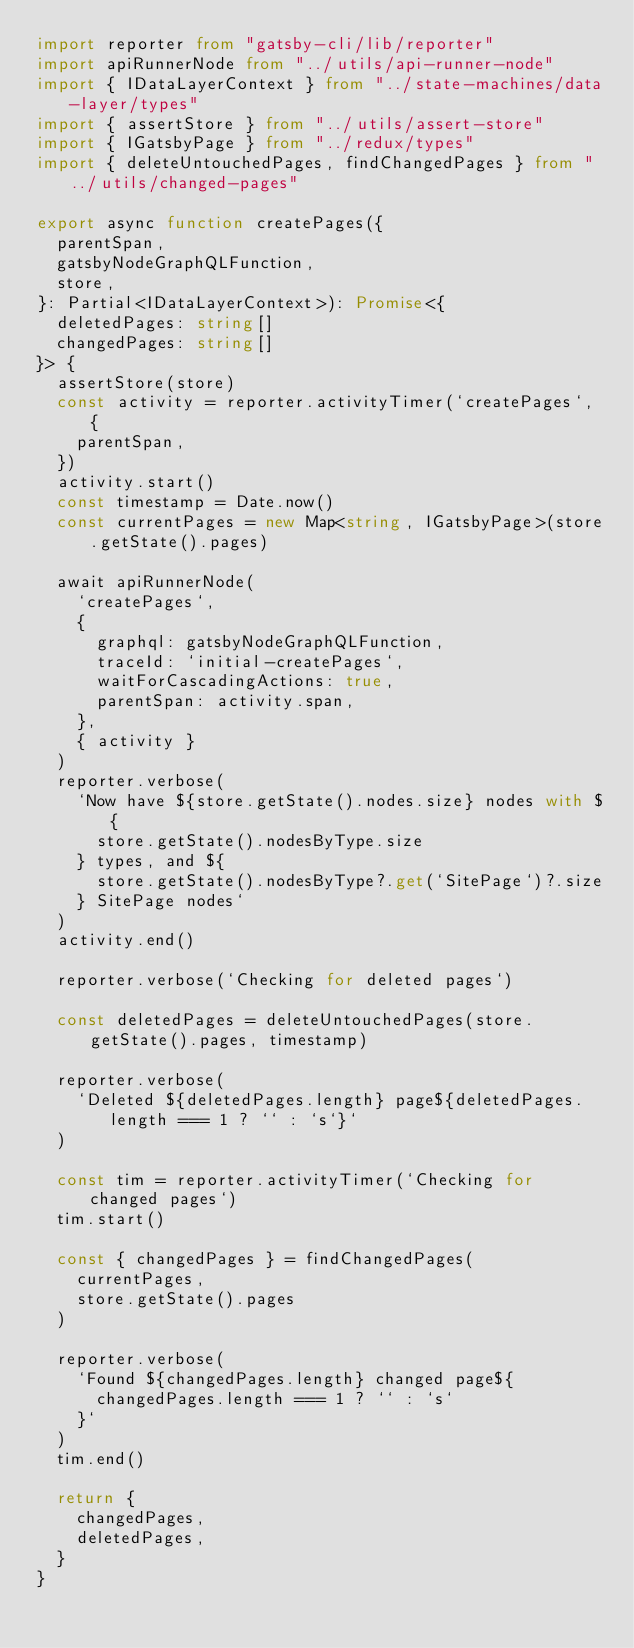<code> <loc_0><loc_0><loc_500><loc_500><_TypeScript_>import reporter from "gatsby-cli/lib/reporter"
import apiRunnerNode from "../utils/api-runner-node"
import { IDataLayerContext } from "../state-machines/data-layer/types"
import { assertStore } from "../utils/assert-store"
import { IGatsbyPage } from "../redux/types"
import { deleteUntouchedPages, findChangedPages } from "../utils/changed-pages"

export async function createPages({
  parentSpan,
  gatsbyNodeGraphQLFunction,
  store,
}: Partial<IDataLayerContext>): Promise<{
  deletedPages: string[]
  changedPages: string[]
}> {
  assertStore(store)
  const activity = reporter.activityTimer(`createPages`, {
    parentSpan,
  })
  activity.start()
  const timestamp = Date.now()
  const currentPages = new Map<string, IGatsbyPage>(store.getState().pages)

  await apiRunnerNode(
    `createPages`,
    {
      graphql: gatsbyNodeGraphQLFunction,
      traceId: `initial-createPages`,
      waitForCascadingActions: true,
      parentSpan: activity.span,
    },
    { activity }
  )
  reporter.verbose(
    `Now have ${store.getState().nodes.size} nodes with ${
      store.getState().nodesByType.size
    } types, and ${
      store.getState().nodesByType?.get(`SitePage`)?.size
    } SitePage nodes`
  )
  activity.end()

  reporter.verbose(`Checking for deleted pages`)

  const deletedPages = deleteUntouchedPages(store.getState().pages, timestamp)

  reporter.verbose(
    `Deleted ${deletedPages.length} page${deletedPages.length === 1 ? `` : `s`}`
  )

  const tim = reporter.activityTimer(`Checking for changed pages`)
  tim.start()

  const { changedPages } = findChangedPages(
    currentPages,
    store.getState().pages
  )

  reporter.verbose(
    `Found ${changedPages.length} changed page${
      changedPages.length === 1 ? `` : `s`
    }`
  )
  tim.end()

  return {
    changedPages,
    deletedPages,
  }
}
</code> 